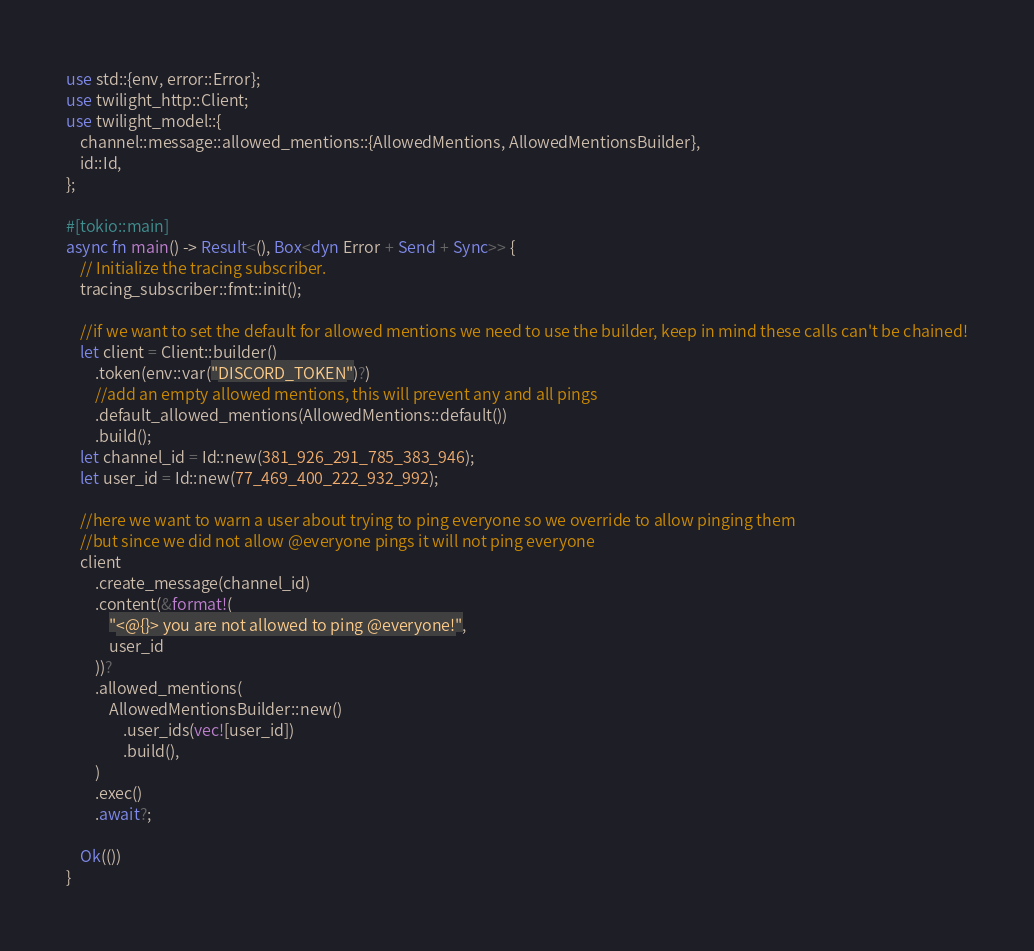Convert code to text. <code><loc_0><loc_0><loc_500><loc_500><_Rust_>use std::{env, error::Error};
use twilight_http::Client;
use twilight_model::{
    channel::message::allowed_mentions::{AllowedMentions, AllowedMentionsBuilder},
    id::Id,
};

#[tokio::main]
async fn main() -> Result<(), Box<dyn Error + Send + Sync>> {
    // Initialize the tracing subscriber.
    tracing_subscriber::fmt::init();

    //if we want to set the default for allowed mentions we need to use the builder, keep in mind these calls can't be chained!
    let client = Client::builder()
        .token(env::var("DISCORD_TOKEN")?)
        //add an empty allowed mentions, this will prevent any and all pings
        .default_allowed_mentions(AllowedMentions::default())
        .build();
    let channel_id = Id::new(381_926_291_785_383_946);
    let user_id = Id::new(77_469_400_222_932_992);

    //here we want to warn a user about trying to ping everyone so we override to allow pinging them
    //but since we did not allow @everyone pings it will not ping everyone
    client
        .create_message(channel_id)
        .content(&format!(
            "<@{}> you are not allowed to ping @everyone!",
            user_id
        ))?
        .allowed_mentions(
            AllowedMentionsBuilder::new()
                .user_ids(vec![user_id])
                .build(),
        )
        .exec()
        .await?;

    Ok(())
}
</code> 